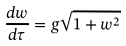Convert formula to latex. <formula><loc_0><loc_0><loc_500><loc_500>\frac { d w } { d \tau } = g \sqrt { 1 + w ^ { 2 } }</formula> 